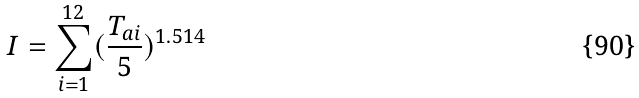Convert formula to latex. <formula><loc_0><loc_0><loc_500><loc_500>I = \sum _ { i = 1 } ^ { 1 2 } ( \frac { T _ { a i } } { 5 } ) ^ { 1 . 5 1 4 }</formula> 